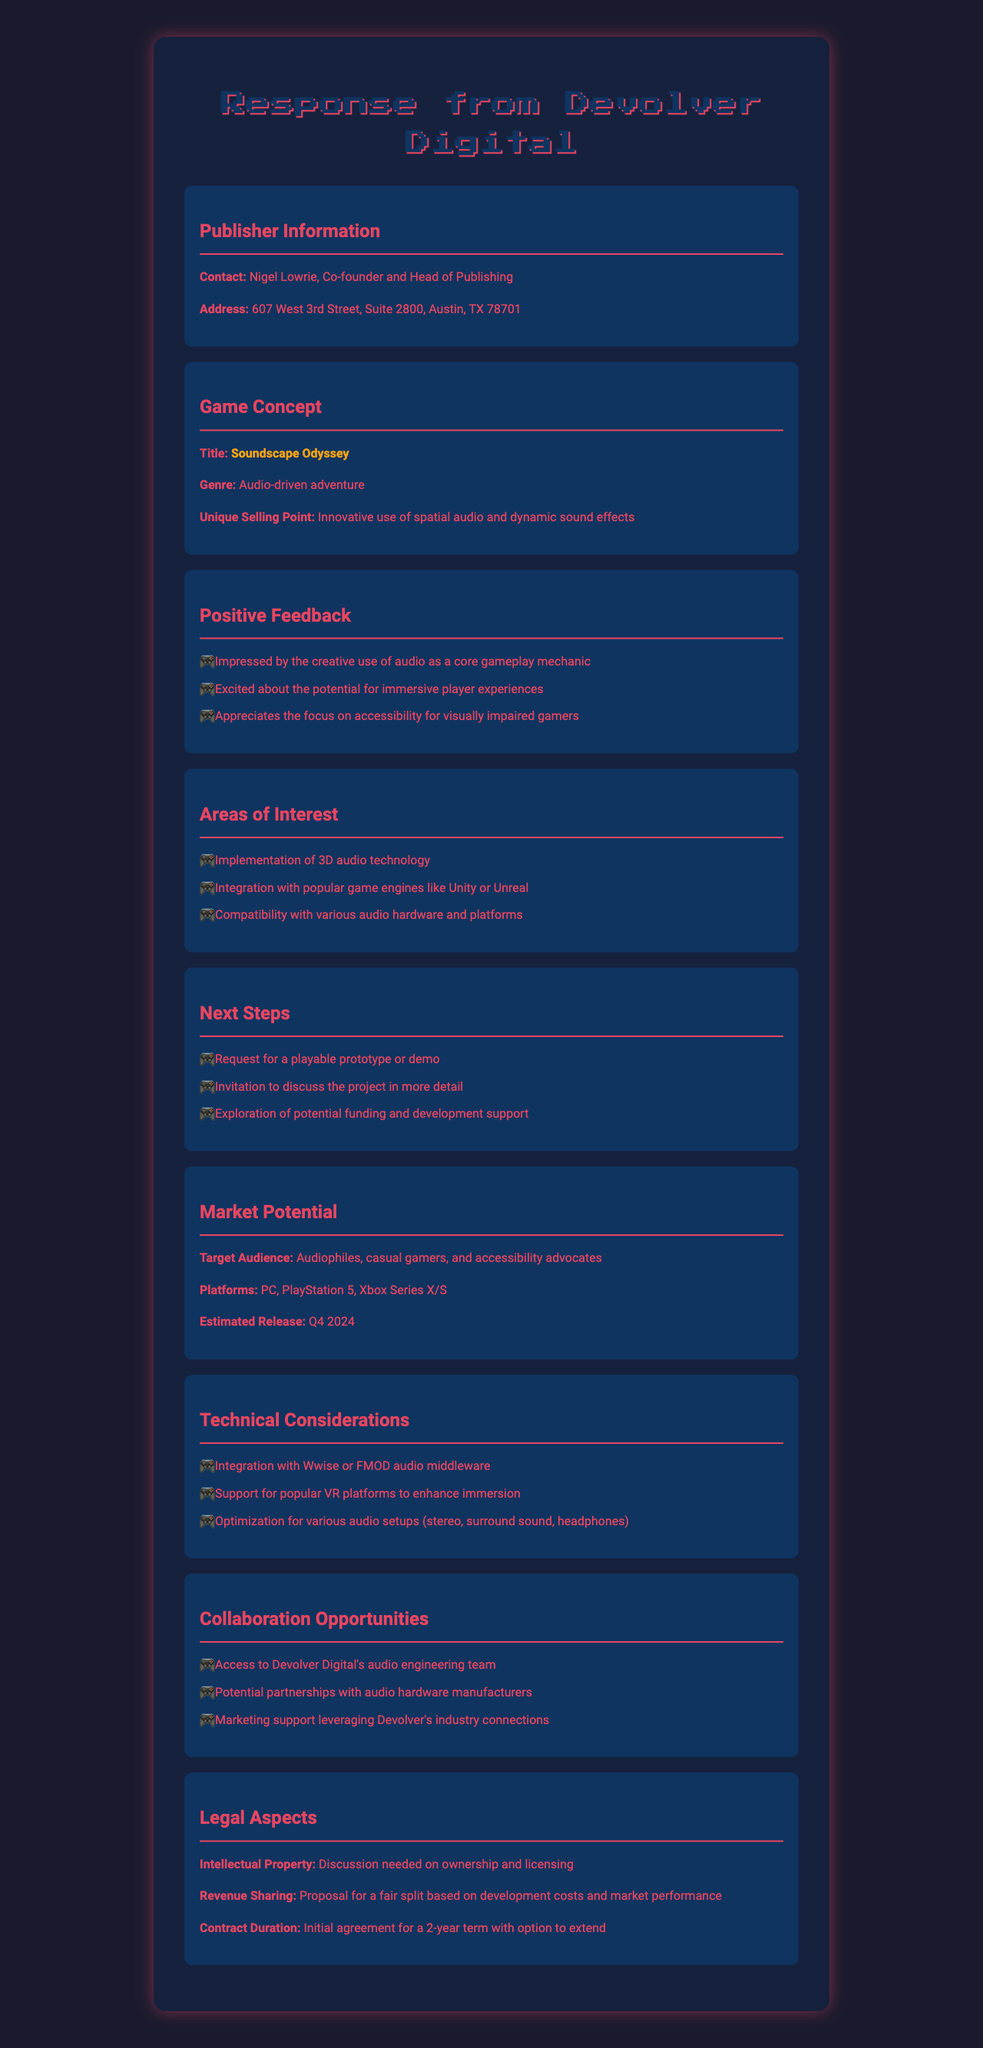What is the name of the publisher? The name of the publisher is mentioned at the beginning of the document under publisher information.
Answer: Devolver Digital Who is the contact person at Devolver Digital? The contact person is specified in the publisher information section of the document.
Answer: Nigel Lowrie What is the title of the game concept? The title of the game is highlighted in the game concept section.
Answer: Soundscape Odyssey What are the possible platforms for the game? The platforms are listed in the market potential section of the document.
Answer: PC, PlayStation 5, Xbox Series X/S What unique selling point is noted for the game? The unique selling point is provided in the game concept section, highlighting the game's special features.
Answer: Innovative use of spatial audio and dynamic sound effects What feedback did the publisher provide about the game's accessibility features? The positive feedback section indicates the publisher's appreciation for accessibility in the game.
Answer: Appreciates the focus on accessibility for visually impaired gamers How long is the initial contract duration proposed? The contract duration is clearly stated in the legal aspects section of the document.
Answer: Initial agreement for a 2-year term What is the estimated release window for the game? The estimated release window is mentioned in the market potential section.
Answer: Q4 2024 What technical consideration involves audio integration? The technical considerations include various aspects related to audio and technology.
Answer: Integration with Wwise or FMOD audio middleware 